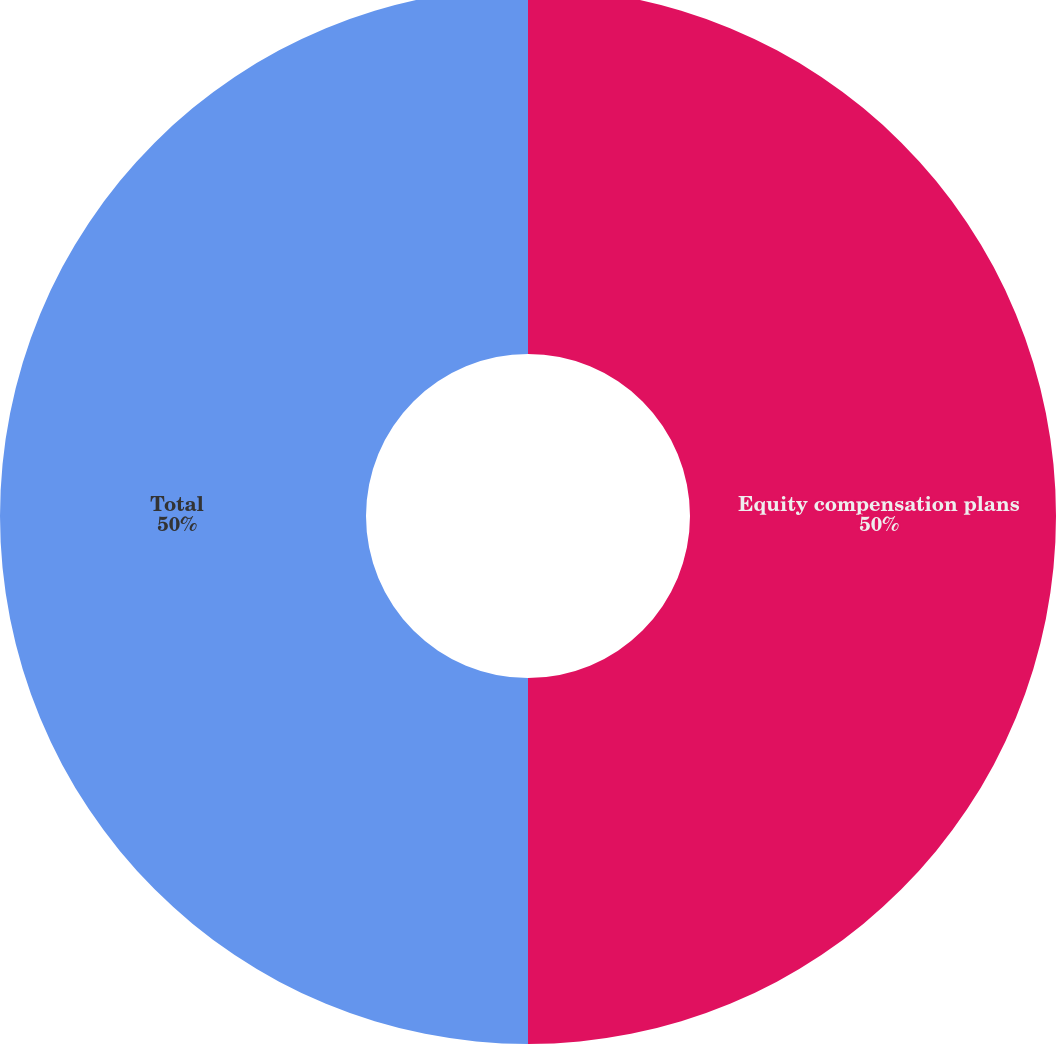Convert chart. <chart><loc_0><loc_0><loc_500><loc_500><pie_chart><fcel>Equity compensation plans<fcel>Total<nl><fcel>50.0%<fcel>50.0%<nl></chart> 